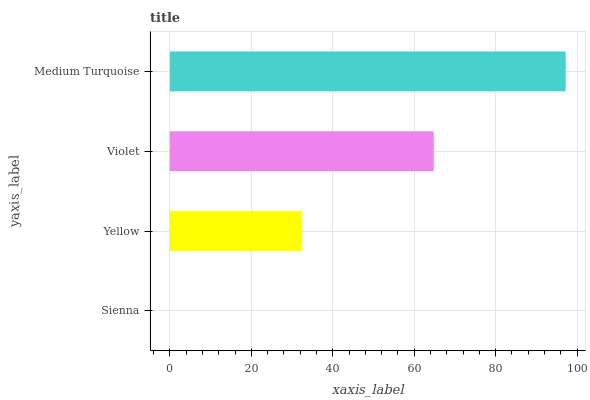Is Sienna the minimum?
Answer yes or no. Yes. Is Medium Turquoise the maximum?
Answer yes or no. Yes. Is Yellow the minimum?
Answer yes or no. No. Is Yellow the maximum?
Answer yes or no. No. Is Yellow greater than Sienna?
Answer yes or no. Yes. Is Sienna less than Yellow?
Answer yes or no. Yes. Is Sienna greater than Yellow?
Answer yes or no. No. Is Yellow less than Sienna?
Answer yes or no. No. Is Violet the high median?
Answer yes or no. Yes. Is Yellow the low median?
Answer yes or no. Yes. Is Sienna the high median?
Answer yes or no. No. Is Violet the low median?
Answer yes or no. No. 